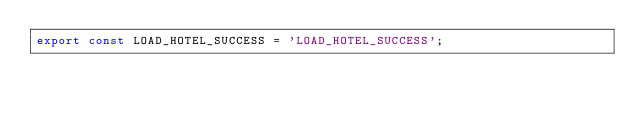Convert code to text. <code><loc_0><loc_0><loc_500><loc_500><_JavaScript_>export const LOAD_HOTEL_SUCCESS = 'LOAD_HOTEL_SUCCESS';
</code> 